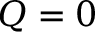<formula> <loc_0><loc_0><loc_500><loc_500>Q = 0</formula> 